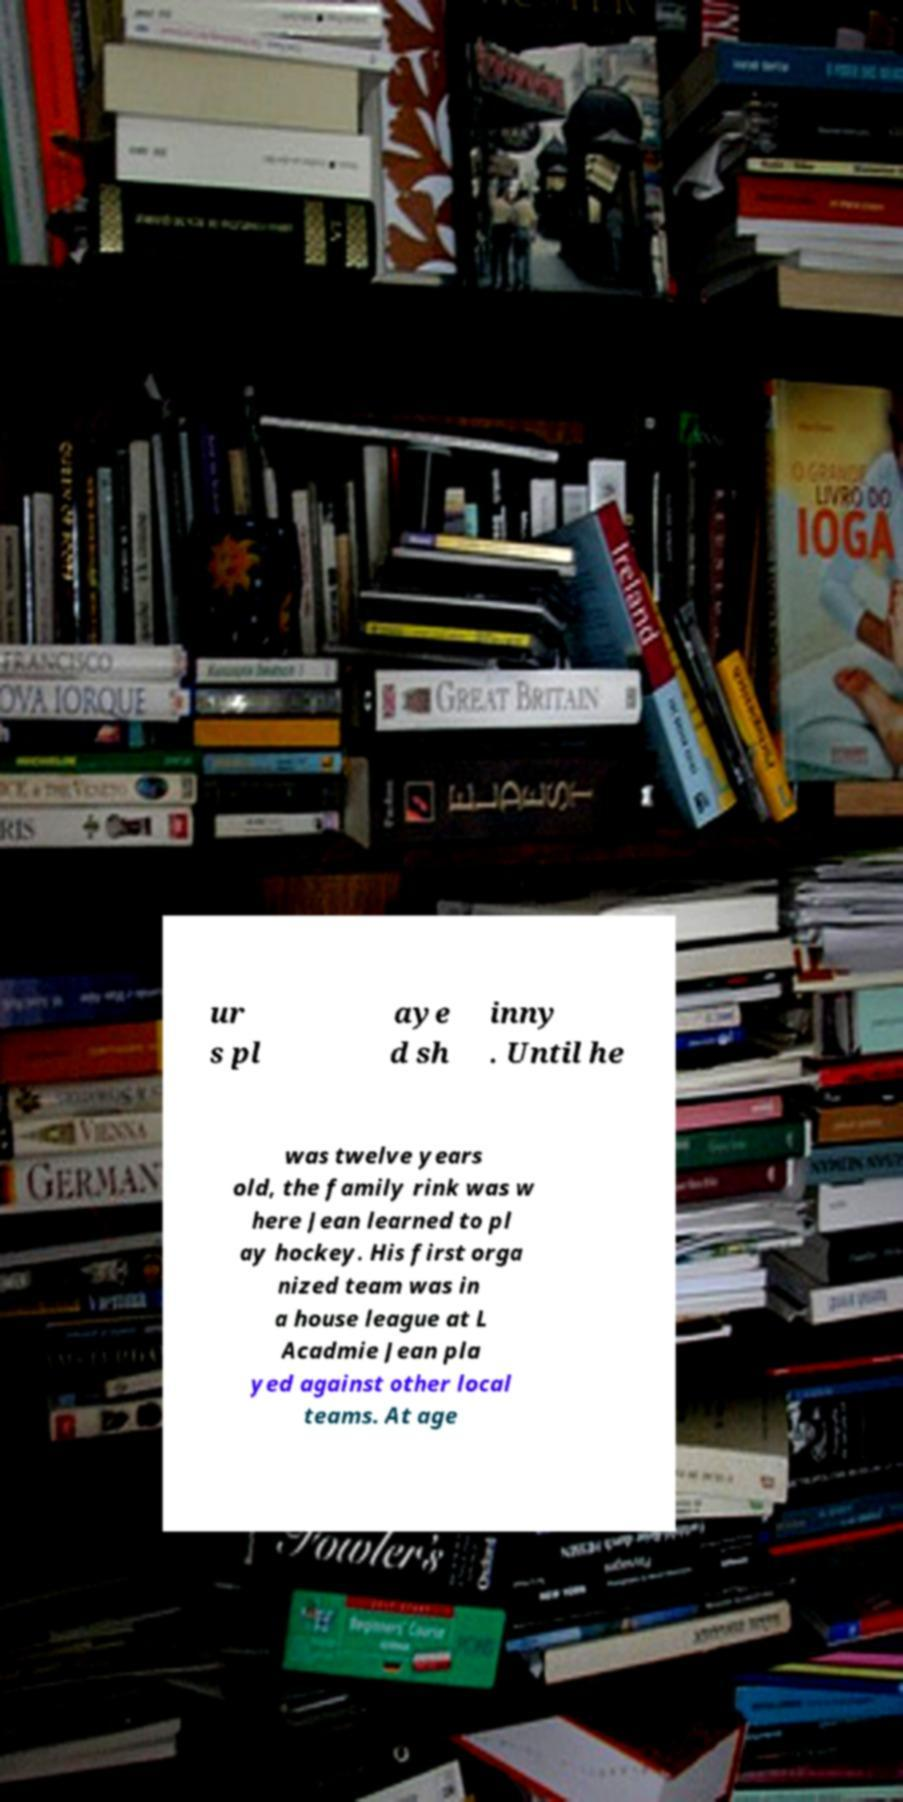I need the written content from this picture converted into text. Can you do that? ur s pl aye d sh inny . Until he was twelve years old, the family rink was w here Jean learned to pl ay hockey. His first orga nized team was in a house league at L Acadmie Jean pla yed against other local teams. At age 